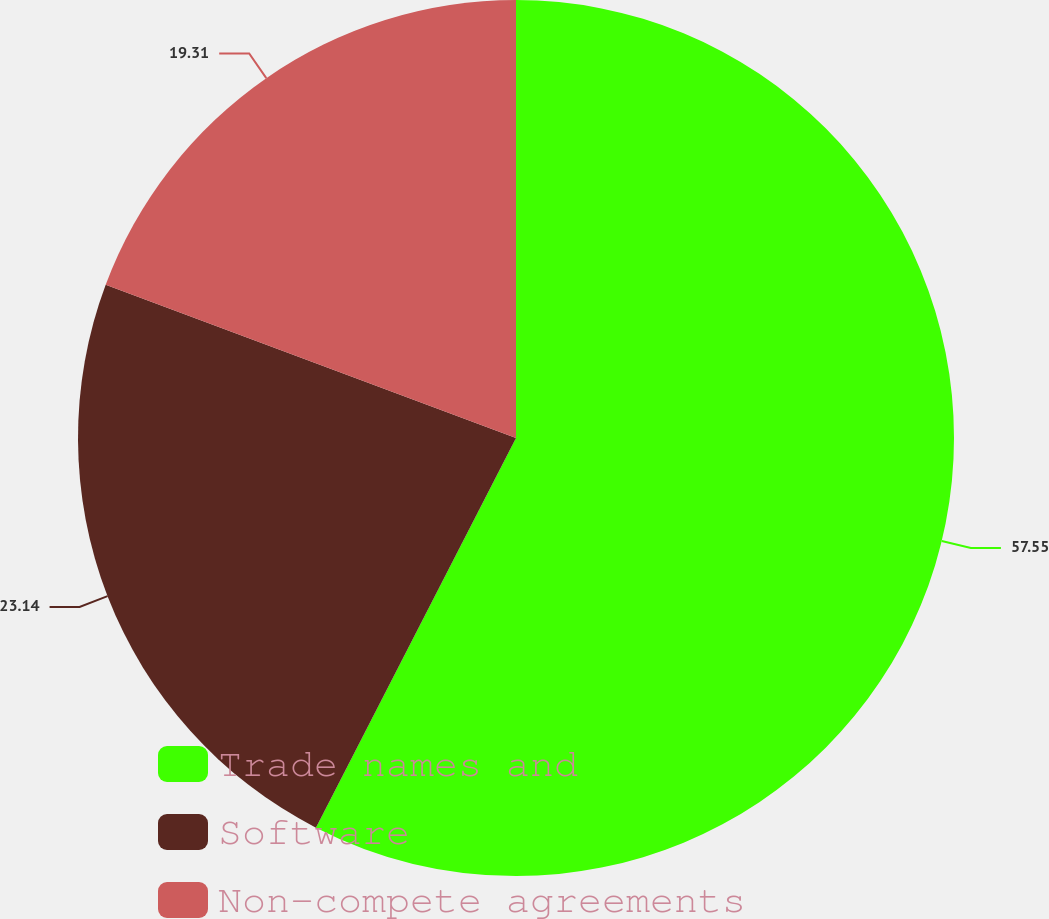<chart> <loc_0><loc_0><loc_500><loc_500><pie_chart><fcel>Trade names and<fcel>Software<fcel>Non-compete agreements<nl><fcel>57.55%<fcel>23.14%<fcel>19.31%<nl></chart> 